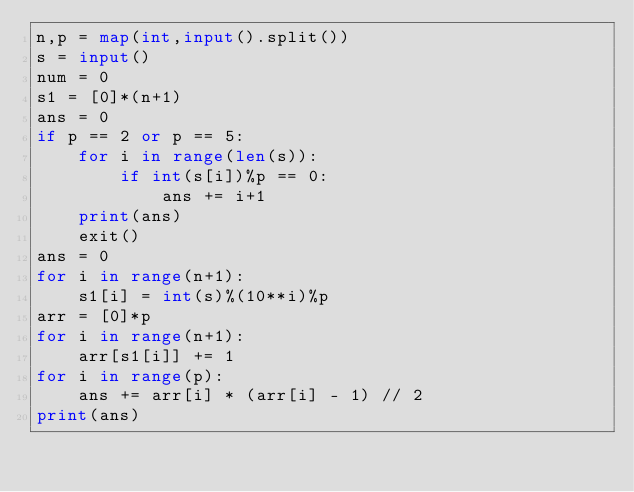Convert code to text. <code><loc_0><loc_0><loc_500><loc_500><_Python_>n,p = map(int,input().split())
s = input()
num = 0
s1 = [0]*(n+1)
ans = 0
if p == 2 or p == 5:
	for i in range(len(s)):
		if int(s[i])%p == 0:
			ans += i+1	
	print(ans)
	exit()
ans = 0
for i in range(n+1):
	s1[i] = int(s)%(10**i)%p
arr = [0]*p
for i in range(n+1):
	arr[s1[i]] += 1
for i in range(p):
	ans += arr[i] * (arr[i] - 1) // 2
print(ans)
</code> 